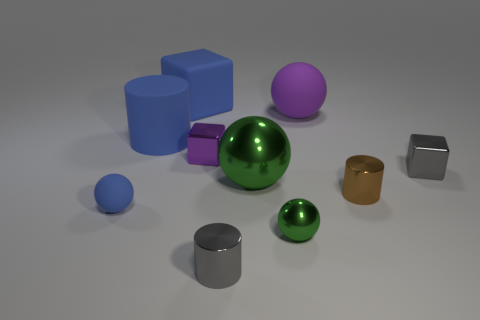There is a object that is the same color as the big matte sphere; what material is it?
Make the answer very short. Metal. Is the rubber cylinder the same color as the small matte ball?
Your response must be concise. Yes. Are there any purple things that are to the left of the green metallic object behind the blue matte ball?
Your answer should be compact. Yes. What number of green spheres are in front of the small object to the left of the small cube on the left side of the tiny brown cylinder?
Provide a succinct answer. 1. Are there fewer tiny gray objects than big red metallic things?
Provide a succinct answer. No. There is a gray metal object left of the gray block; does it have the same shape as the gray object that is behind the small gray cylinder?
Ensure brevity in your answer.  No. What is the color of the large metal thing?
Make the answer very short. Green. What number of metal objects are either tiny brown spheres or green balls?
Your response must be concise. 2. What is the color of the other metallic object that is the same shape as the tiny brown metal thing?
Provide a succinct answer. Gray. Are any small blue cylinders visible?
Give a very brief answer. No. 